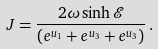Convert formula to latex. <formula><loc_0><loc_0><loc_500><loc_500>J = \frac { 2 \omega \sinh \mathcal { E } } { ( e ^ { u _ { 1 } } + e ^ { u _ { 3 } } + e ^ { u _ { 3 } } ) } \, .</formula> 